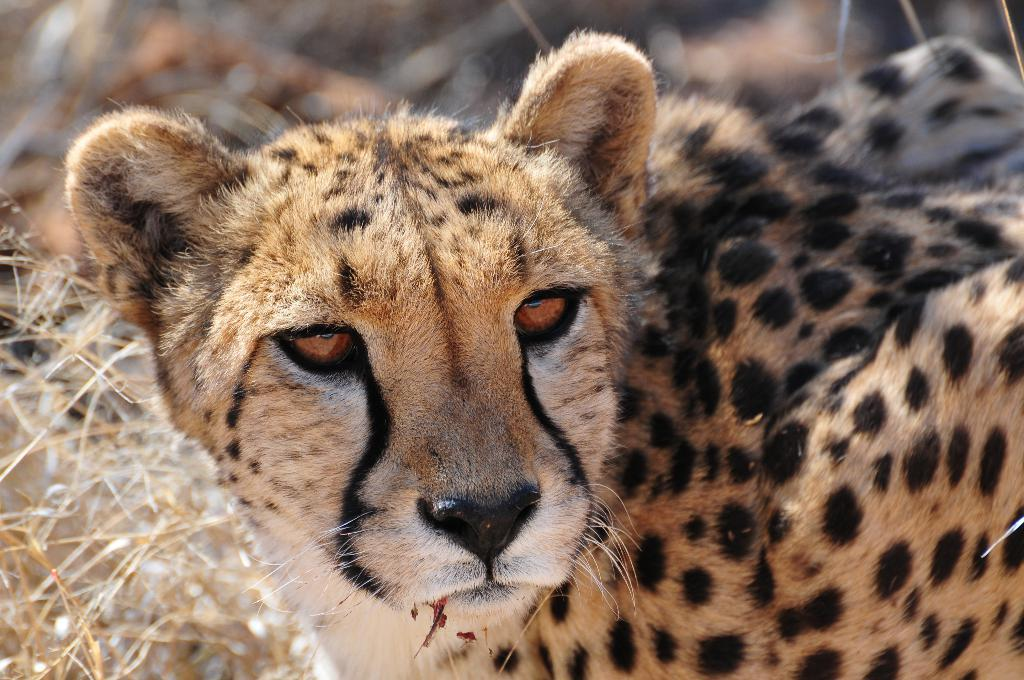What animal is the main subject of the image? There is a leopard in the image. Can you describe the background of the image? The background of the image is blurred. Can you see any bears at the seashore in the image? There are no bears or seashore present in the image; it features a leopard with a blurred background. 